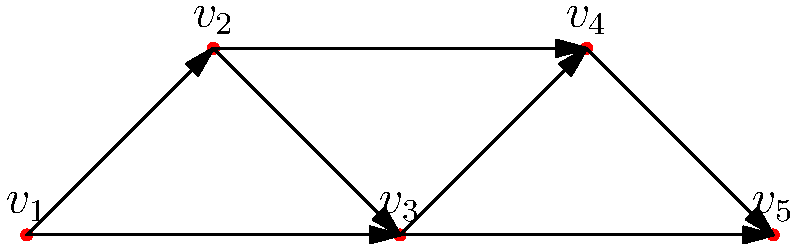Consider the directed graph representing a complex drill movement for a marching band formation. Each vertex represents a position, and each edge represents a possible movement between positions. How many different paths are there from $v_1$ to $v_5$, and what is the length of the longest possible path? To solve this problem, we need to analyze the directed graph and count the possible paths from $v_1$ to $v_5$. Let's break it down step-by-step:

1. Identify all possible paths from $v_1$ to $v_5$:
   a) $v_1 \rightarrow v_2 \rightarrow v_3 \rightarrow v_4 \rightarrow v_5$
   b) $v_1 \rightarrow v_2 \rightarrow v_3 \rightarrow v_5$
   c) $v_1 \rightarrow v_3 \rightarrow v_4 \rightarrow v_5$
   d) $v_1 \rightarrow v_3 \rightarrow v_5$

2. Count the number of paths:
   There are 4 distinct paths from $v_1$ to $v_5$.

3. Determine the length of each path:
   a) Length: 4 edges
   b) Length: 3 edges
   c) Length: 3 edges
   d) Length: 2 edges

4. Identify the longest path:
   The longest path is $v_1 \rightarrow v_2 \rightarrow v_3 \rightarrow v_4 \rightarrow v_5$, with a length of 4 edges.

Therefore, there are 4 different paths from $v_1$ to $v_5$, and the length of the longest possible path is 4 edges.
Answer: 4 paths; longest path length: 4 